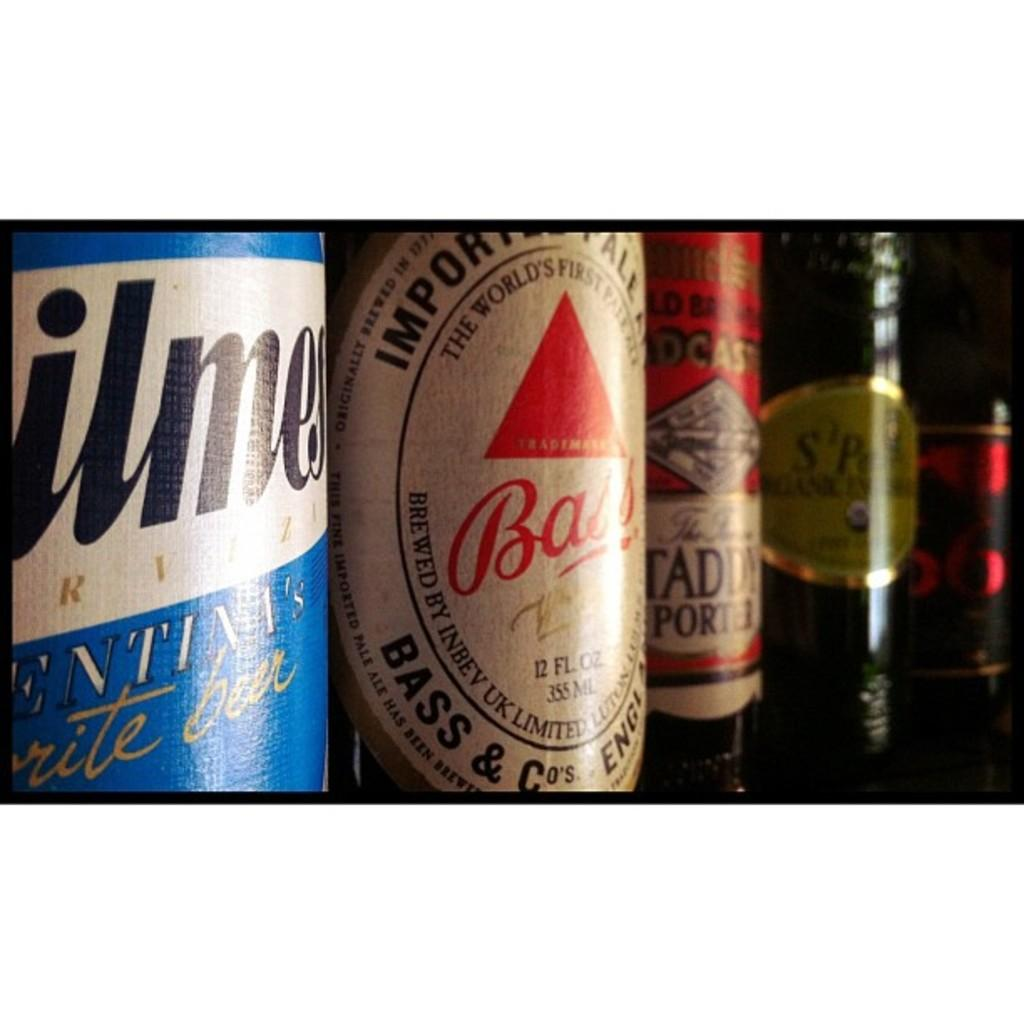<image>
Describe the image concisely. the word bass is on one of the beer bottles 